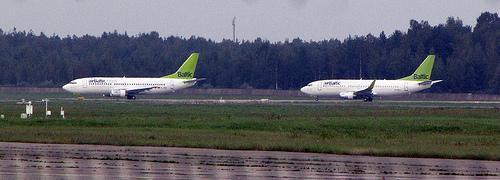How many planes are there?
Give a very brief answer. 2. 